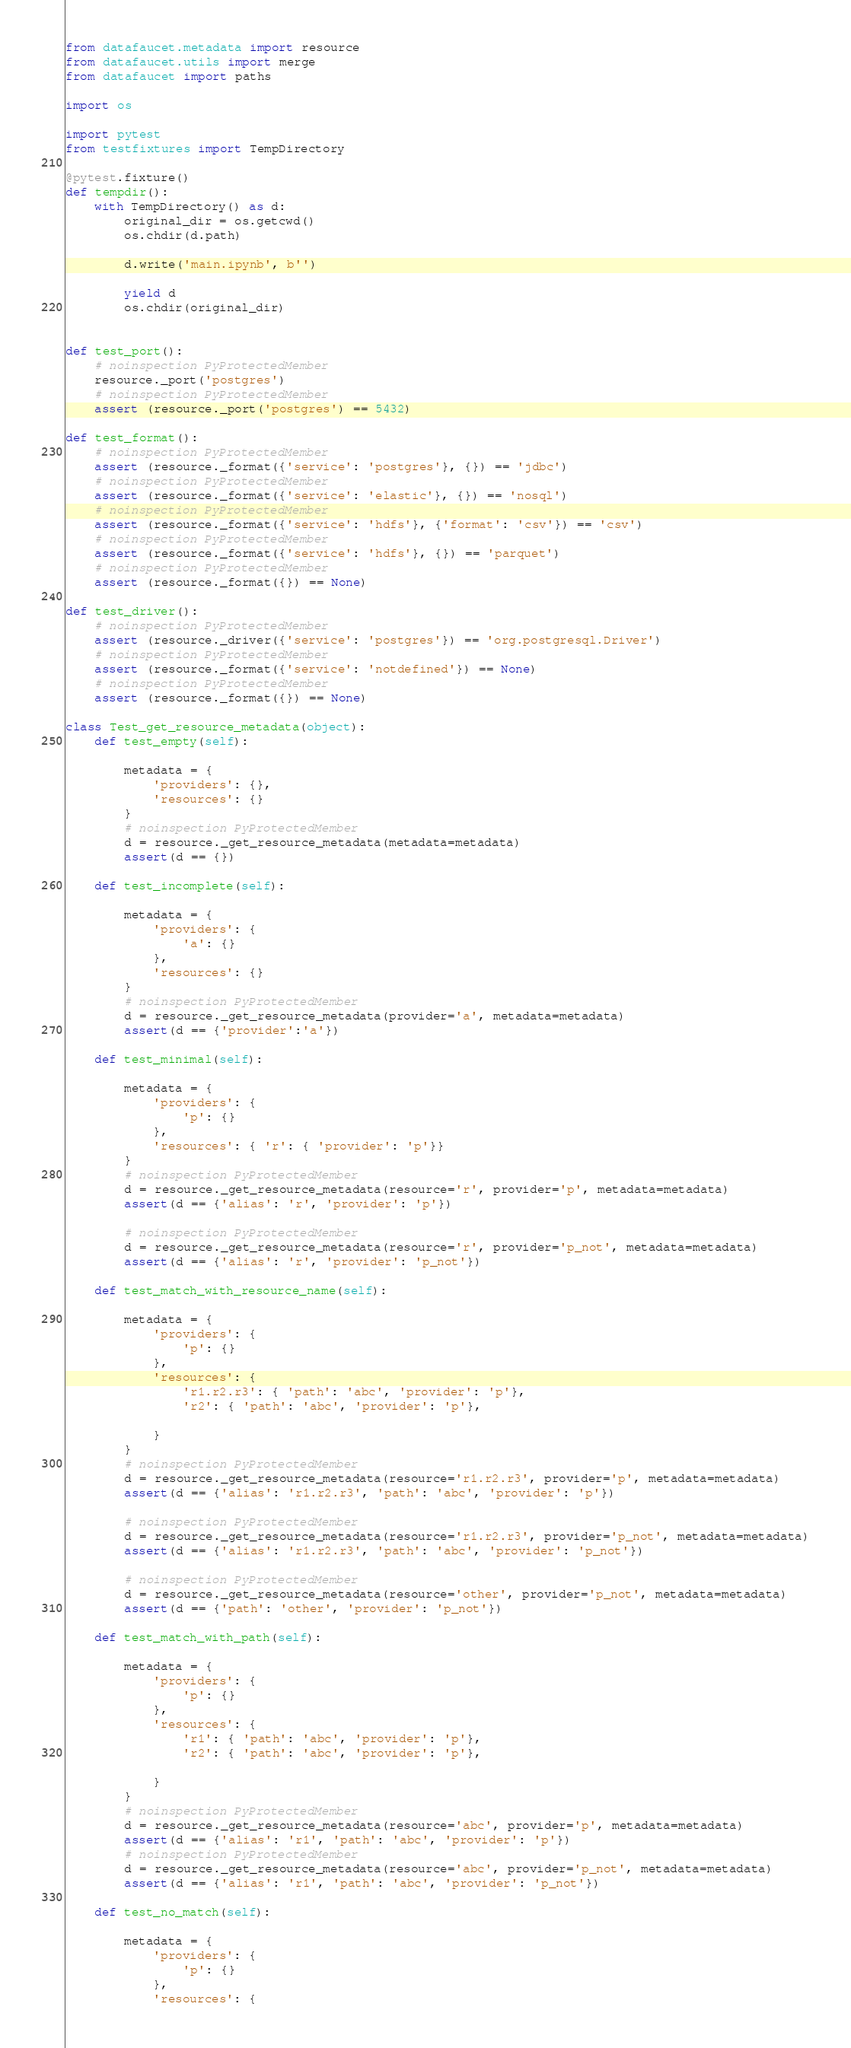Convert code to text. <code><loc_0><loc_0><loc_500><loc_500><_Python_>from datafaucet.metadata import resource
from datafaucet.utils import merge
from datafaucet import paths

import os

import pytest
from testfixtures import TempDirectory

@pytest.fixture()
def tempdir():
    with TempDirectory() as d:
        original_dir = os.getcwd()
        os.chdir(d.path)

        d.write('main.ipynb', b'')

        yield d
        os.chdir(original_dir)


def test_port():
    # noinspection PyProtectedMember
    resource._port('postgres')
    # noinspection PyProtectedMember
    assert (resource._port('postgres') == 5432)

def test_format():
    # noinspection PyProtectedMember
    assert (resource._format({'service': 'postgres'}, {}) == 'jdbc')
    # noinspection PyProtectedMember
    assert (resource._format({'service': 'elastic'}, {}) == 'nosql')
    # noinspection PyProtectedMember
    assert (resource._format({'service': 'hdfs'}, {'format': 'csv'}) == 'csv')
    # noinspection PyProtectedMember
    assert (resource._format({'service': 'hdfs'}, {}) == 'parquet')
    # noinspection PyProtectedMember
    assert (resource._format({}) == None)

def test_driver():
    # noinspection PyProtectedMember
    assert (resource._driver({'service': 'postgres'}) == 'org.postgresql.Driver')
    # noinspection PyProtectedMember
    assert (resource._format({'service': 'notdefined'}) == None)
    # noinspection PyProtectedMember
    assert (resource._format({}) == None)

class Test_get_resource_metadata(object):
    def test_empty(self):

        metadata = {
            'providers': {},
            'resources': {}
        }
        # noinspection PyProtectedMember
        d = resource._get_resource_metadata(metadata=metadata)
        assert(d == {})

    def test_incomplete(self):

        metadata = {
            'providers': {
                'a': {}
            },
            'resources': {}
        }
        # noinspection PyProtectedMember
        d = resource._get_resource_metadata(provider='a', metadata=metadata)
        assert(d == {'provider':'a'})

    def test_minimal(self):

        metadata = {
            'providers': {
                'p': {}
            },
            'resources': { 'r': { 'provider': 'p'}}
        }
        # noinspection PyProtectedMember
        d = resource._get_resource_metadata(resource='r', provider='p', metadata=metadata)
        assert(d == {'alias': 'r', 'provider': 'p'})

        # noinspection PyProtectedMember
        d = resource._get_resource_metadata(resource='r', provider='p_not', metadata=metadata)
        assert(d == {'alias': 'r', 'provider': 'p_not'})

    def test_match_with_resource_name(self):

        metadata = {
            'providers': {
                'p': {}
            },
            'resources': {
                'r1.r2.r3': { 'path': 'abc', 'provider': 'p'},
                'r2': { 'path': 'abc', 'provider': 'p'},

            }
        }
        # noinspection PyProtectedMember
        d = resource._get_resource_metadata(resource='r1.r2.r3', provider='p', metadata=metadata)
        assert(d == {'alias': 'r1.r2.r3', 'path': 'abc', 'provider': 'p'})

        # noinspection PyProtectedMember
        d = resource._get_resource_metadata(resource='r1.r2.r3', provider='p_not', metadata=metadata)
        assert(d == {'alias': 'r1.r2.r3', 'path': 'abc', 'provider': 'p_not'})

        # noinspection PyProtectedMember
        d = resource._get_resource_metadata(resource='other', provider='p_not', metadata=metadata)
        assert(d == {'path': 'other', 'provider': 'p_not'})

    def test_match_with_path(self):

        metadata = {
            'providers': {
                'p': {}
            },
            'resources': {
                'r1': { 'path': 'abc', 'provider': 'p'},
                'r2': { 'path': 'abc', 'provider': 'p'},

            }
        }
        # noinspection PyProtectedMember
        d = resource._get_resource_metadata(resource='abc', provider='p', metadata=metadata)
        assert(d == {'alias': 'r1', 'path': 'abc', 'provider': 'p'})
        # noinspection PyProtectedMember
        d = resource._get_resource_metadata(resource='abc', provider='p_not', metadata=metadata)
        assert(d == {'alias': 'r1', 'path': 'abc', 'provider': 'p_not'})

    def test_no_match(self):

        metadata = {
            'providers': {
                'p': {}
            },
            'resources': {</code> 